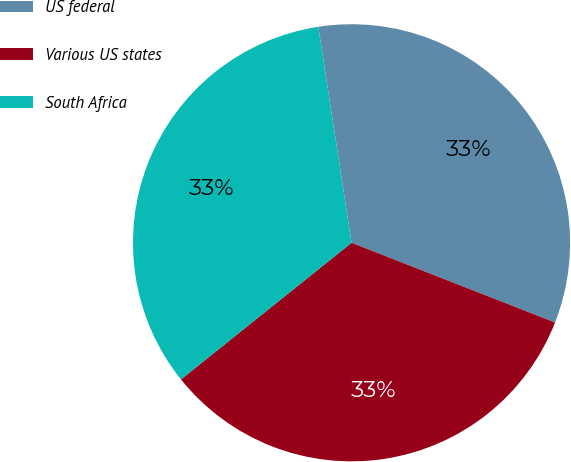<chart> <loc_0><loc_0><loc_500><loc_500><pie_chart><fcel>US federal<fcel>Various US states<fcel>South Africa<nl><fcel>33.38%<fcel>33.31%<fcel>33.32%<nl></chart> 